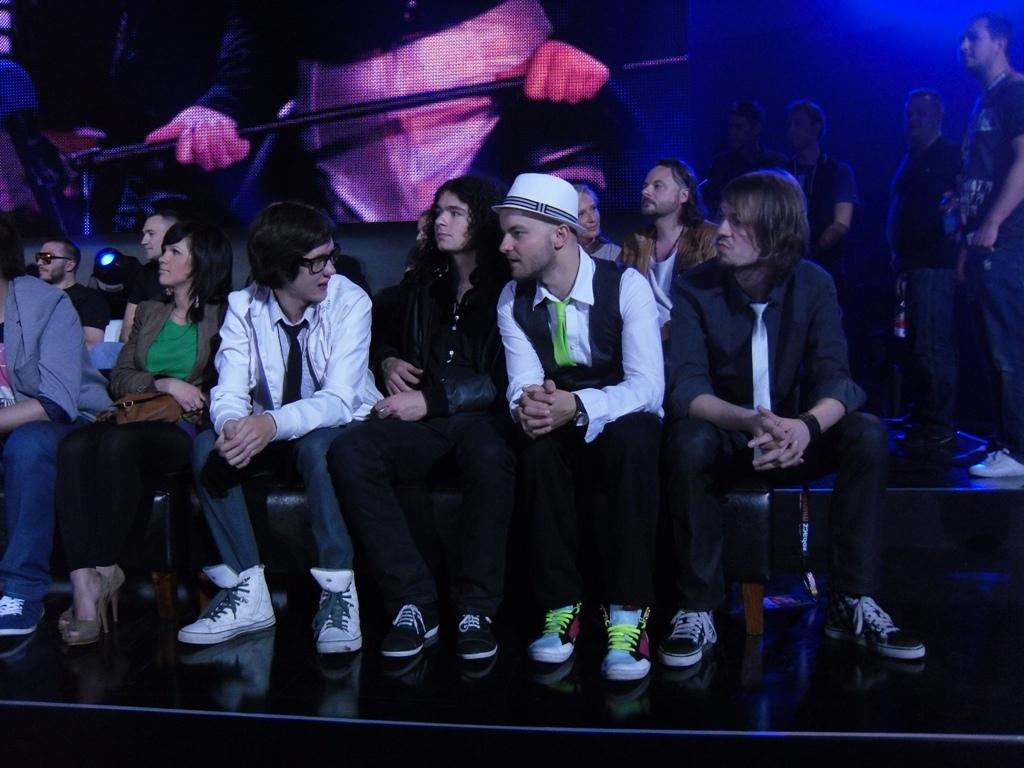What are the people in the image doing? The people in the image are sitting and standing. What can be seen in the background of the image? There is a poster in the background of the image. What is the poster depicting? The poster depicts a person holding a rod. How many sisters are present in the image? There is no mention of a sister in the image, so it cannot be determined if any are present. 